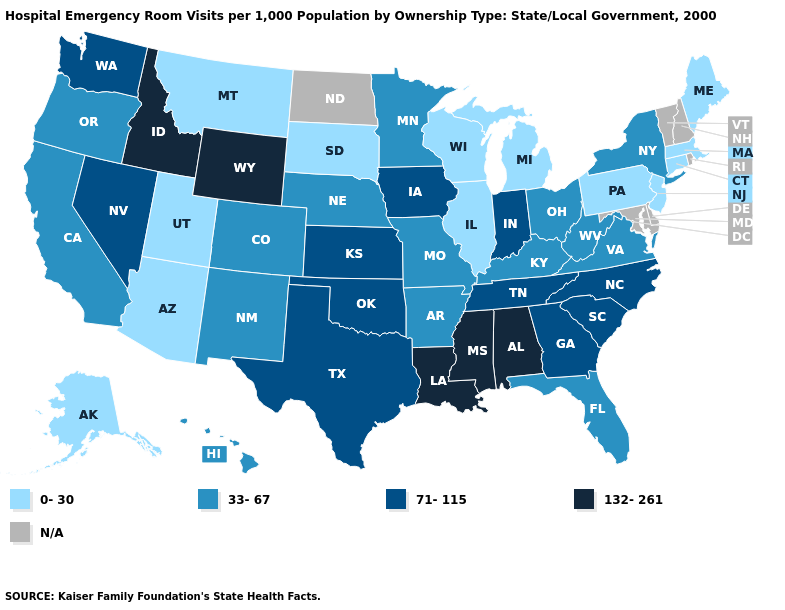What is the lowest value in states that border Georgia?
Write a very short answer. 33-67. Does Mississippi have the highest value in the South?
Answer briefly. Yes. Which states have the highest value in the USA?
Short answer required. Alabama, Idaho, Louisiana, Mississippi, Wyoming. Among the states that border Arkansas , does Louisiana have the lowest value?
Short answer required. No. Among the states that border Arizona , which have the lowest value?
Write a very short answer. Utah. What is the value of Iowa?
Be succinct. 71-115. Among the states that border Montana , which have the lowest value?
Concise answer only. South Dakota. What is the value of Hawaii?
Be succinct. 33-67. Which states hav the highest value in the MidWest?
Quick response, please. Indiana, Iowa, Kansas. Among the states that border Montana , which have the lowest value?
Quick response, please. South Dakota. Name the states that have a value in the range 0-30?
Answer briefly. Alaska, Arizona, Connecticut, Illinois, Maine, Massachusetts, Michigan, Montana, New Jersey, Pennsylvania, South Dakota, Utah, Wisconsin. What is the value of Minnesota?
Concise answer only. 33-67. What is the lowest value in the USA?
Short answer required. 0-30. 